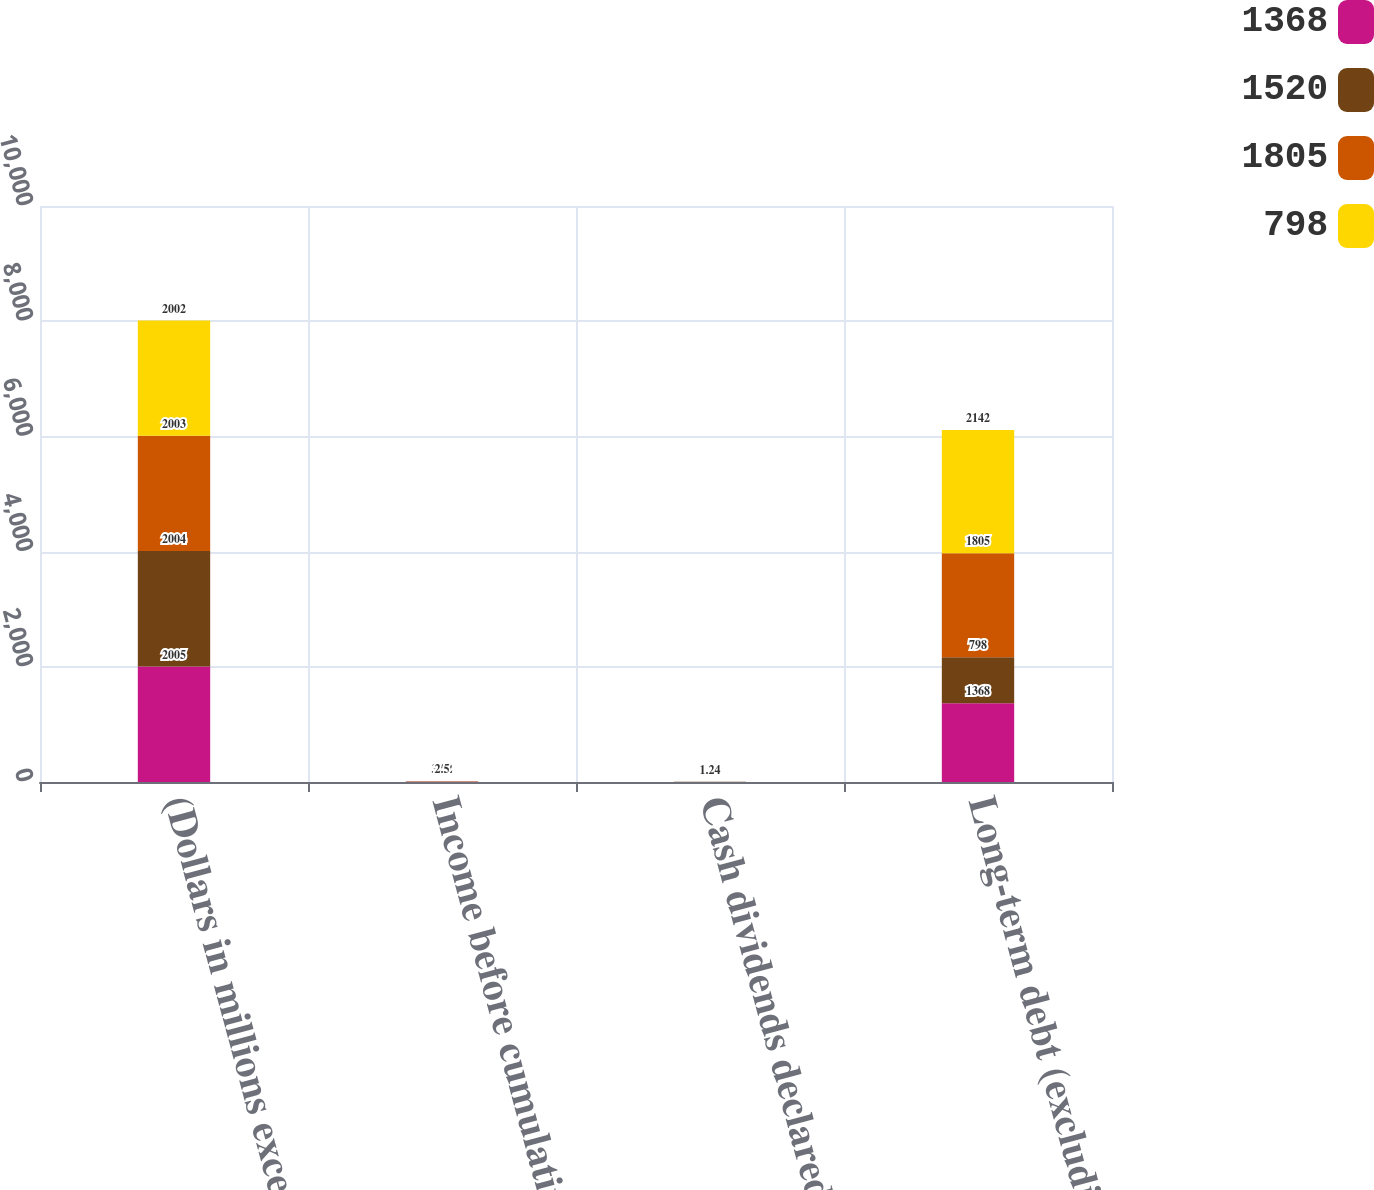Convert chart. <chart><loc_0><loc_0><loc_500><loc_500><stacked_bar_chart><ecel><fcel>(Dollars in millions except<fcel>Income before cumulative<fcel>Cash dividends declared and<fcel>Long-term debt (excluding<nl><fcel>1368<fcel>2005<fcel>4.16<fcel>1.68<fcel>1368<nl><fcel>1520<fcel>2004<fcel>3.75<fcel>1.44<fcel>798<nl><fcel>1805<fcel>2003<fcel>3.02<fcel>1.32<fcel>1805<nl><fcel>798<fcel>2002<fcel>2.5<fcel>1.24<fcel>2142<nl></chart> 